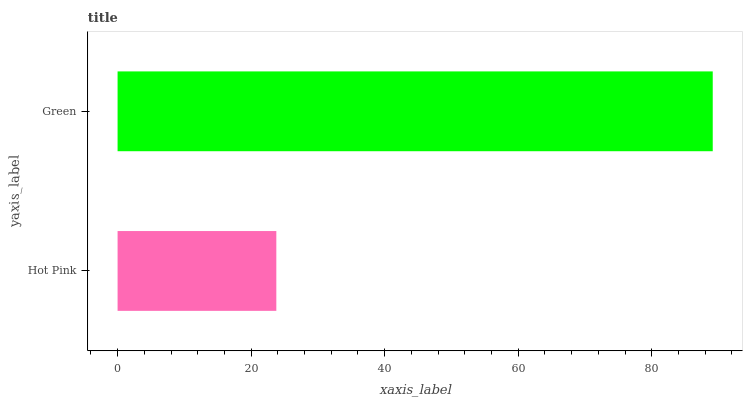Is Hot Pink the minimum?
Answer yes or no. Yes. Is Green the maximum?
Answer yes or no. Yes. Is Green the minimum?
Answer yes or no. No. Is Green greater than Hot Pink?
Answer yes or no. Yes. Is Hot Pink less than Green?
Answer yes or no. Yes. Is Hot Pink greater than Green?
Answer yes or no. No. Is Green less than Hot Pink?
Answer yes or no. No. Is Green the high median?
Answer yes or no. Yes. Is Hot Pink the low median?
Answer yes or no. Yes. Is Hot Pink the high median?
Answer yes or no. No. Is Green the low median?
Answer yes or no. No. 